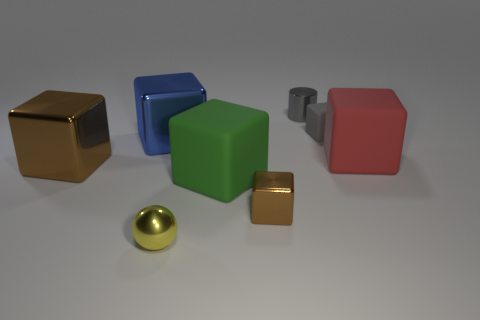There is a small yellow shiny thing; what number of brown cubes are right of it?
Make the answer very short. 1. Does the brown metallic object that is on the right side of the large green matte block have the same shape as the matte thing that is on the left side of the tiny gray metal cylinder?
Your response must be concise. Yes. What number of other things are the same color as the sphere?
Offer a terse response. 0. What is the material of the tiny cube to the right of the small brown object that is to the left of the small object on the right side of the tiny gray shiny cylinder?
Your answer should be compact. Rubber. There is a block right of the gray thing in front of the gray metallic thing; what is its material?
Your answer should be very brief. Rubber. Are there fewer small brown objects that are on the right side of the red matte object than tiny spheres?
Keep it short and to the point. Yes. What is the shape of the brown shiny object that is on the left side of the yellow thing?
Offer a very short reply. Cube. Do the gray metallic cylinder and the brown shiny object in front of the large brown metal object have the same size?
Your answer should be very brief. Yes. Are there any large brown cubes that have the same material as the tiny sphere?
Ensure brevity in your answer.  Yes. How many cubes are either gray rubber objects or big red objects?
Provide a succinct answer. 2. 